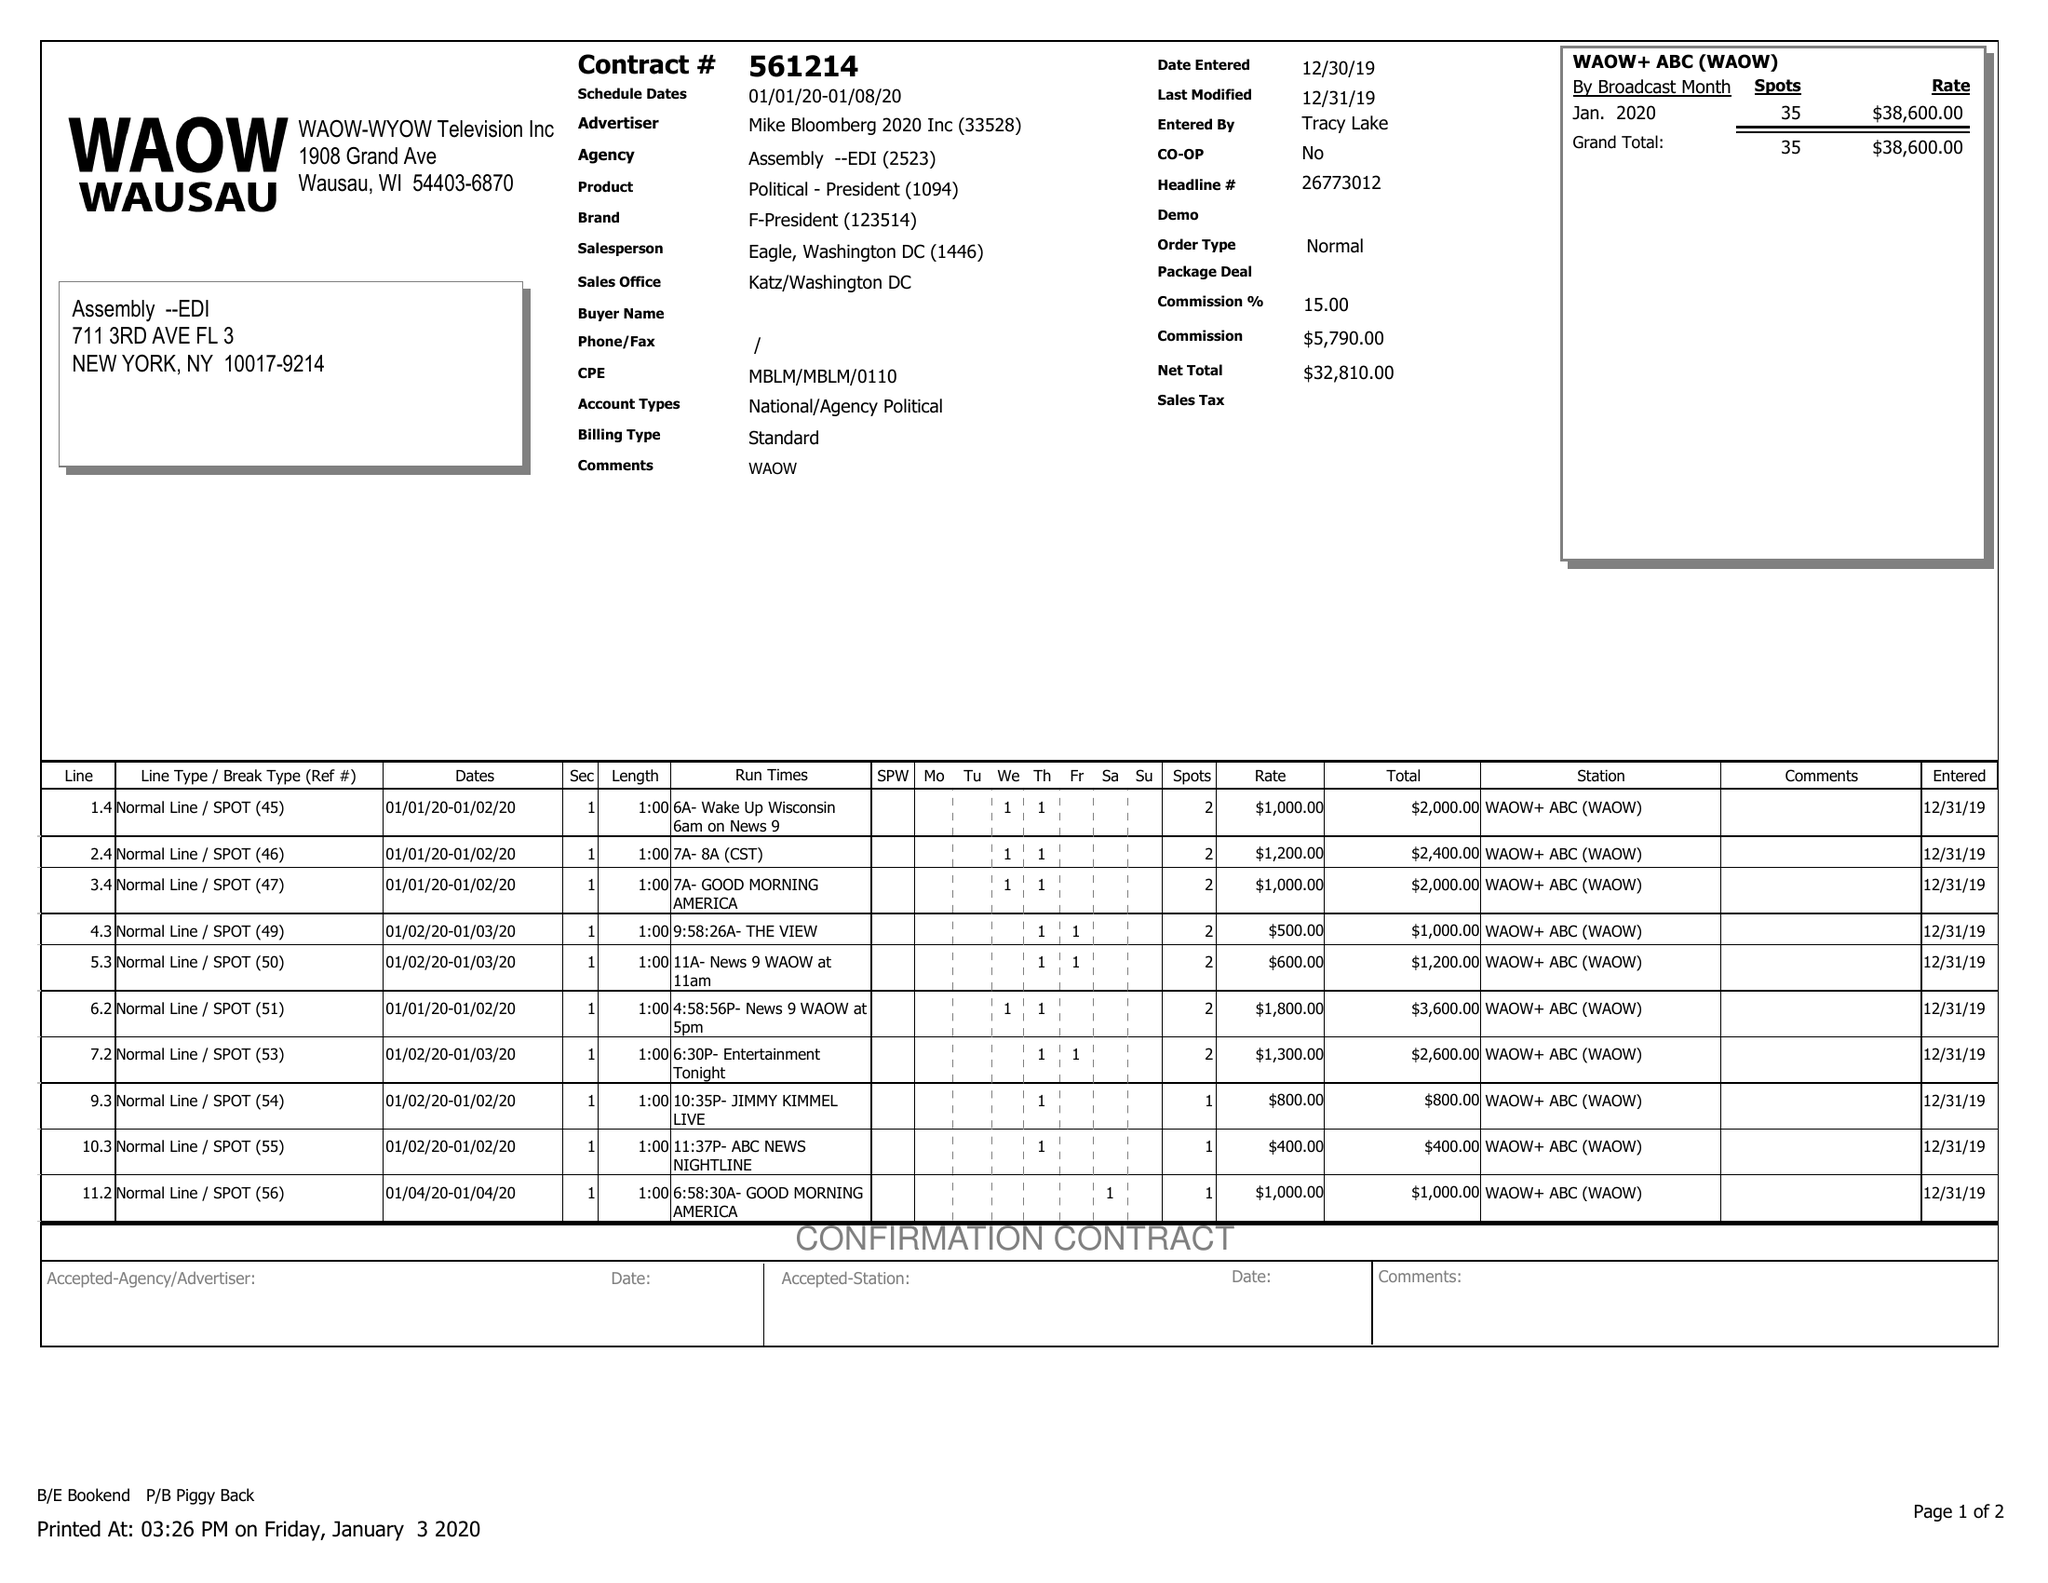What is the value for the advertiser?
Answer the question using a single word or phrase. MIKE BLOOMBERG 2020 INC 